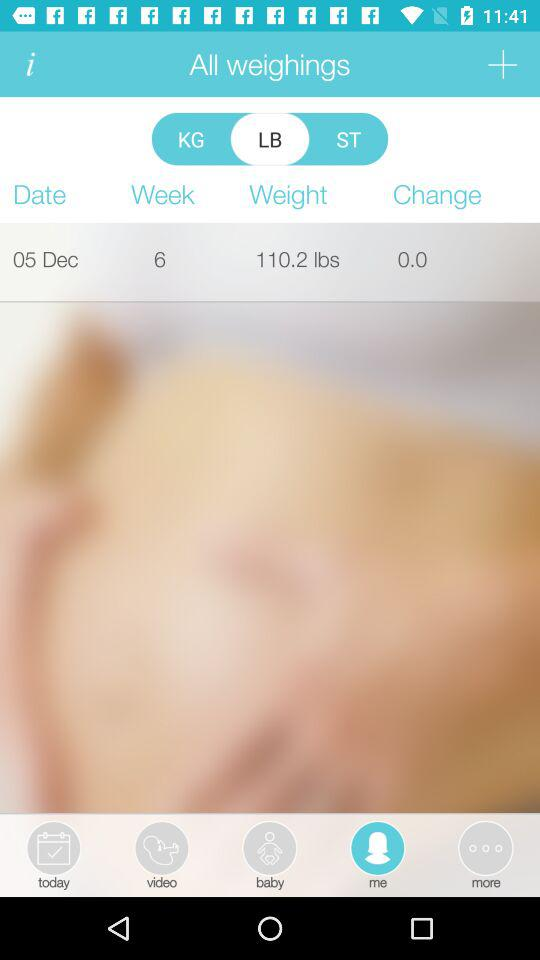Which unit is selected for weight? The selected unit for weight is "LB". 